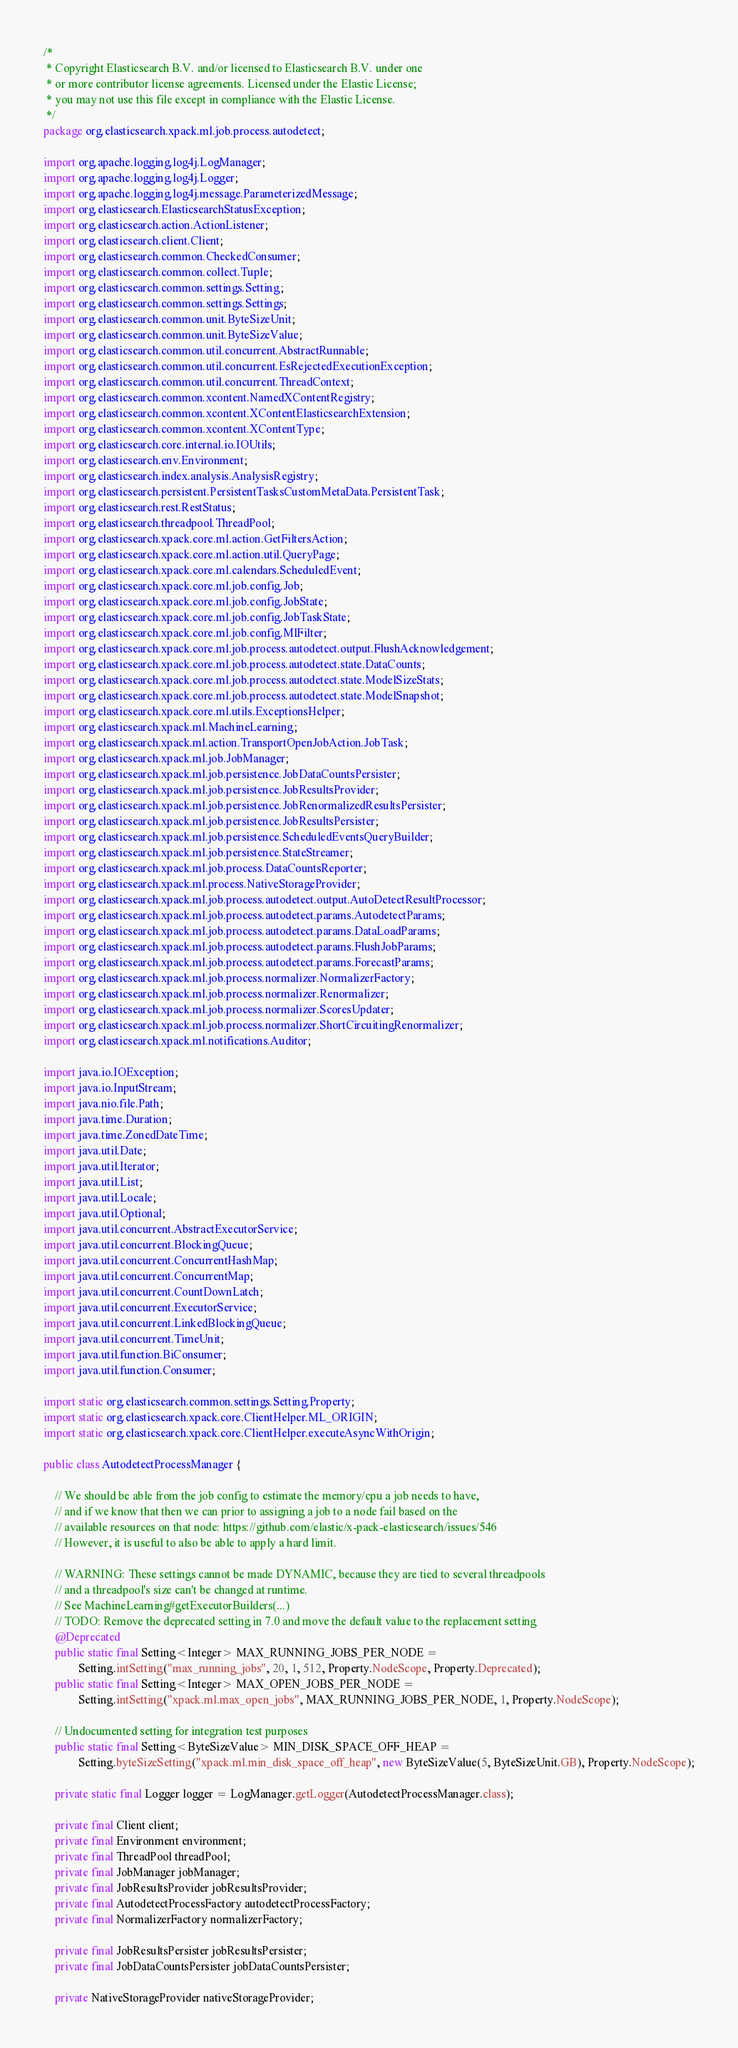Convert code to text. <code><loc_0><loc_0><loc_500><loc_500><_Java_>/*
 * Copyright Elasticsearch B.V. and/or licensed to Elasticsearch B.V. under one
 * or more contributor license agreements. Licensed under the Elastic License;
 * you may not use this file except in compliance with the Elastic License.
 */
package org.elasticsearch.xpack.ml.job.process.autodetect;

import org.apache.logging.log4j.LogManager;
import org.apache.logging.log4j.Logger;
import org.apache.logging.log4j.message.ParameterizedMessage;
import org.elasticsearch.ElasticsearchStatusException;
import org.elasticsearch.action.ActionListener;
import org.elasticsearch.client.Client;
import org.elasticsearch.common.CheckedConsumer;
import org.elasticsearch.common.collect.Tuple;
import org.elasticsearch.common.settings.Setting;
import org.elasticsearch.common.settings.Settings;
import org.elasticsearch.common.unit.ByteSizeUnit;
import org.elasticsearch.common.unit.ByteSizeValue;
import org.elasticsearch.common.util.concurrent.AbstractRunnable;
import org.elasticsearch.common.util.concurrent.EsRejectedExecutionException;
import org.elasticsearch.common.util.concurrent.ThreadContext;
import org.elasticsearch.common.xcontent.NamedXContentRegistry;
import org.elasticsearch.common.xcontent.XContentElasticsearchExtension;
import org.elasticsearch.common.xcontent.XContentType;
import org.elasticsearch.core.internal.io.IOUtils;
import org.elasticsearch.env.Environment;
import org.elasticsearch.index.analysis.AnalysisRegistry;
import org.elasticsearch.persistent.PersistentTasksCustomMetaData.PersistentTask;
import org.elasticsearch.rest.RestStatus;
import org.elasticsearch.threadpool.ThreadPool;
import org.elasticsearch.xpack.core.ml.action.GetFiltersAction;
import org.elasticsearch.xpack.core.ml.action.util.QueryPage;
import org.elasticsearch.xpack.core.ml.calendars.ScheduledEvent;
import org.elasticsearch.xpack.core.ml.job.config.Job;
import org.elasticsearch.xpack.core.ml.job.config.JobState;
import org.elasticsearch.xpack.core.ml.job.config.JobTaskState;
import org.elasticsearch.xpack.core.ml.job.config.MlFilter;
import org.elasticsearch.xpack.core.ml.job.process.autodetect.output.FlushAcknowledgement;
import org.elasticsearch.xpack.core.ml.job.process.autodetect.state.DataCounts;
import org.elasticsearch.xpack.core.ml.job.process.autodetect.state.ModelSizeStats;
import org.elasticsearch.xpack.core.ml.job.process.autodetect.state.ModelSnapshot;
import org.elasticsearch.xpack.core.ml.utils.ExceptionsHelper;
import org.elasticsearch.xpack.ml.MachineLearning;
import org.elasticsearch.xpack.ml.action.TransportOpenJobAction.JobTask;
import org.elasticsearch.xpack.ml.job.JobManager;
import org.elasticsearch.xpack.ml.job.persistence.JobDataCountsPersister;
import org.elasticsearch.xpack.ml.job.persistence.JobResultsProvider;
import org.elasticsearch.xpack.ml.job.persistence.JobRenormalizedResultsPersister;
import org.elasticsearch.xpack.ml.job.persistence.JobResultsPersister;
import org.elasticsearch.xpack.ml.job.persistence.ScheduledEventsQueryBuilder;
import org.elasticsearch.xpack.ml.job.persistence.StateStreamer;
import org.elasticsearch.xpack.ml.job.process.DataCountsReporter;
import org.elasticsearch.xpack.ml.process.NativeStorageProvider;
import org.elasticsearch.xpack.ml.job.process.autodetect.output.AutoDetectResultProcessor;
import org.elasticsearch.xpack.ml.job.process.autodetect.params.AutodetectParams;
import org.elasticsearch.xpack.ml.job.process.autodetect.params.DataLoadParams;
import org.elasticsearch.xpack.ml.job.process.autodetect.params.FlushJobParams;
import org.elasticsearch.xpack.ml.job.process.autodetect.params.ForecastParams;
import org.elasticsearch.xpack.ml.job.process.normalizer.NormalizerFactory;
import org.elasticsearch.xpack.ml.job.process.normalizer.Renormalizer;
import org.elasticsearch.xpack.ml.job.process.normalizer.ScoresUpdater;
import org.elasticsearch.xpack.ml.job.process.normalizer.ShortCircuitingRenormalizer;
import org.elasticsearch.xpack.ml.notifications.Auditor;

import java.io.IOException;
import java.io.InputStream;
import java.nio.file.Path;
import java.time.Duration;
import java.time.ZonedDateTime;
import java.util.Date;
import java.util.Iterator;
import java.util.List;
import java.util.Locale;
import java.util.Optional;
import java.util.concurrent.AbstractExecutorService;
import java.util.concurrent.BlockingQueue;
import java.util.concurrent.ConcurrentHashMap;
import java.util.concurrent.ConcurrentMap;
import java.util.concurrent.CountDownLatch;
import java.util.concurrent.ExecutorService;
import java.util.concurrent.LinkedBlockingQueue;
import java.util.concurrent.TimeUnit;
import java.util.function.BiConsumer;
import java.util.function.Consumer;

import static org.elasticsearch.common.settings.Setting.Property;
import static org.elasticsearch.xpack.core.ClientHelper.ML_ORIGIN;
import static org.elasticsearch.xpack.core.ClientHelper.executeAsyncWithOrigin;

public class AutodetectProcessManager {

    // We should be able from the job config to estimate the memory/cpu a job needs to have,
    // and if we know that then we can prior to assigning a job to a node fail based on the
    // available resources on that node: https://github.com/elastic/x-pack-elasticsearch/issues/546
    // However, it is useful to also be able to apply a hard limit.

    // WARNING: These settings cannot be made DYNAMIC, because they are tied to several threadpools
    // and a threadpool's size can't be changed at runtime.
    // See MachineLearning#getExecutorBuilders(...)
    // TODO: Remove the deprecated setting in 7.0 and move the default value to the replacement setting
    @Deprecated
    public static final Setting<Integer> MAX_RUNNING_JOBS_PER_NODE =
            Setting.intSetting("max_running_jobs", 20, 1, 512, Property.NodeScope, Property.Deprecated);
    public static final Setting<Integer> MAX_OPEN_JOBS_PER_NODE =
            Setting.intSetting("xpack.ml.max_open_jobs", MAX_RUNNING_JOBS_PER_NODE, 1, Property.NodeScope);

    // Undocumented setting for integration test purposes
    public static final Setting<ByteSizeValue> MIN_DISK_SPACE_OFF_HEAP =
            Setting.byteSizeSetting("xpack.ml.min_disk_space_off_heap", new ByteSizeValue(5, ByteSizeUnit.GB), Property.NodeScope);

    private static final Logger logger = LogManager.getLogger(AutodetectProcessManager.class);

    private final Client client;
    private final Environment environment;
    private final ThreadPool threadPool;
    private final JobManager jobManager;
    private final JobResultsProvider jobResultsProvider;
    private final AutodetectProcessFactory autodetectProcessFactory;
    private final NormalizerFactory normalizerFactory;

    private final JobResultsPersister jobResultsPersister;
    private final JobDataCountsPersister jobDataCountsPersister;

    private NativeStorageProvider nativeStorageProvider;</code> 